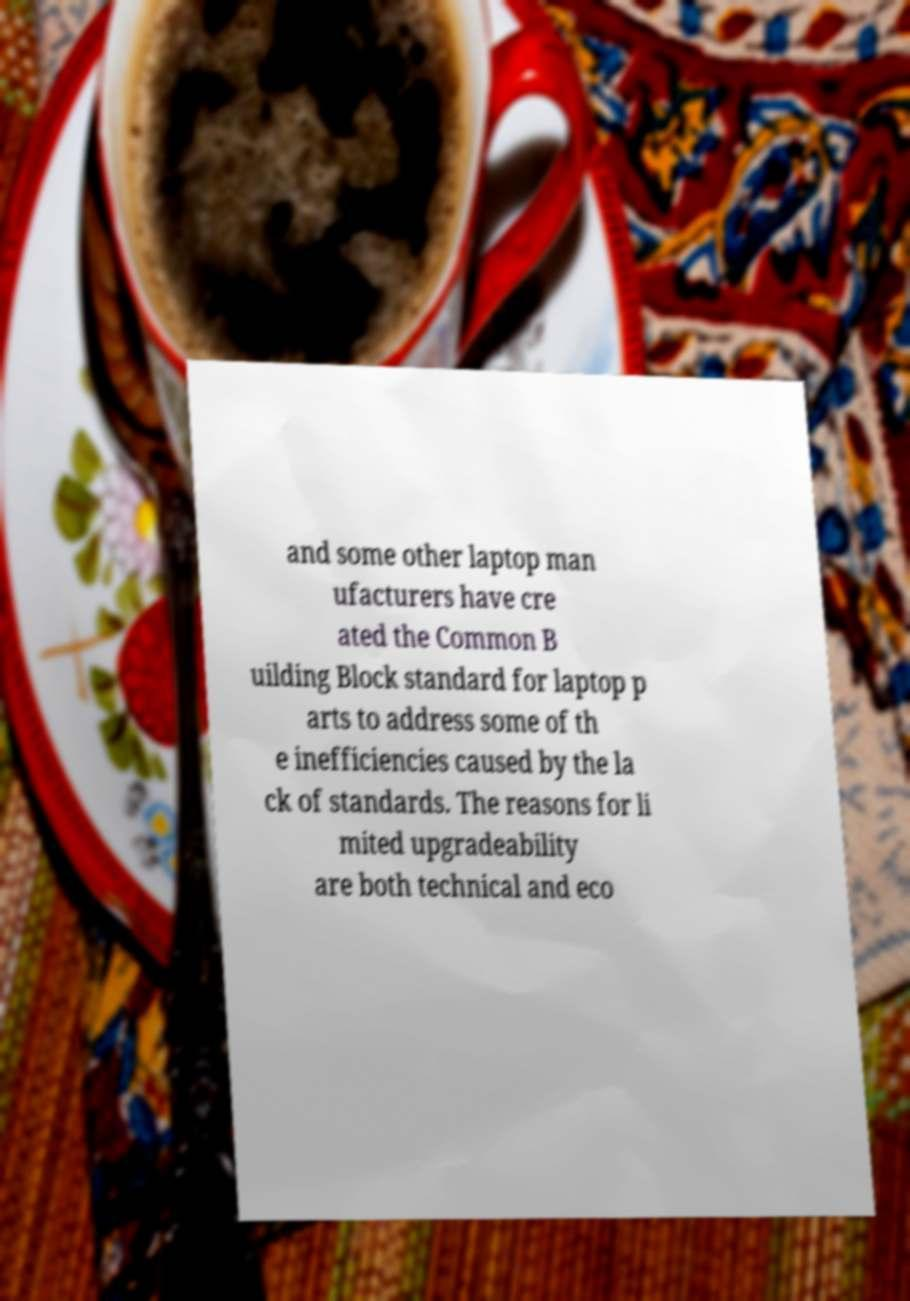There's text embedded in this image that I need extracted. Can you transcribe it verbatim? and some other laptop man ufacturers have cre ated the Common B uilding Block standard for laptop p arts to address some of th e inefficiencies caused by the la ck of standards. The reasons for li mited upgradeability are both technical and eco 